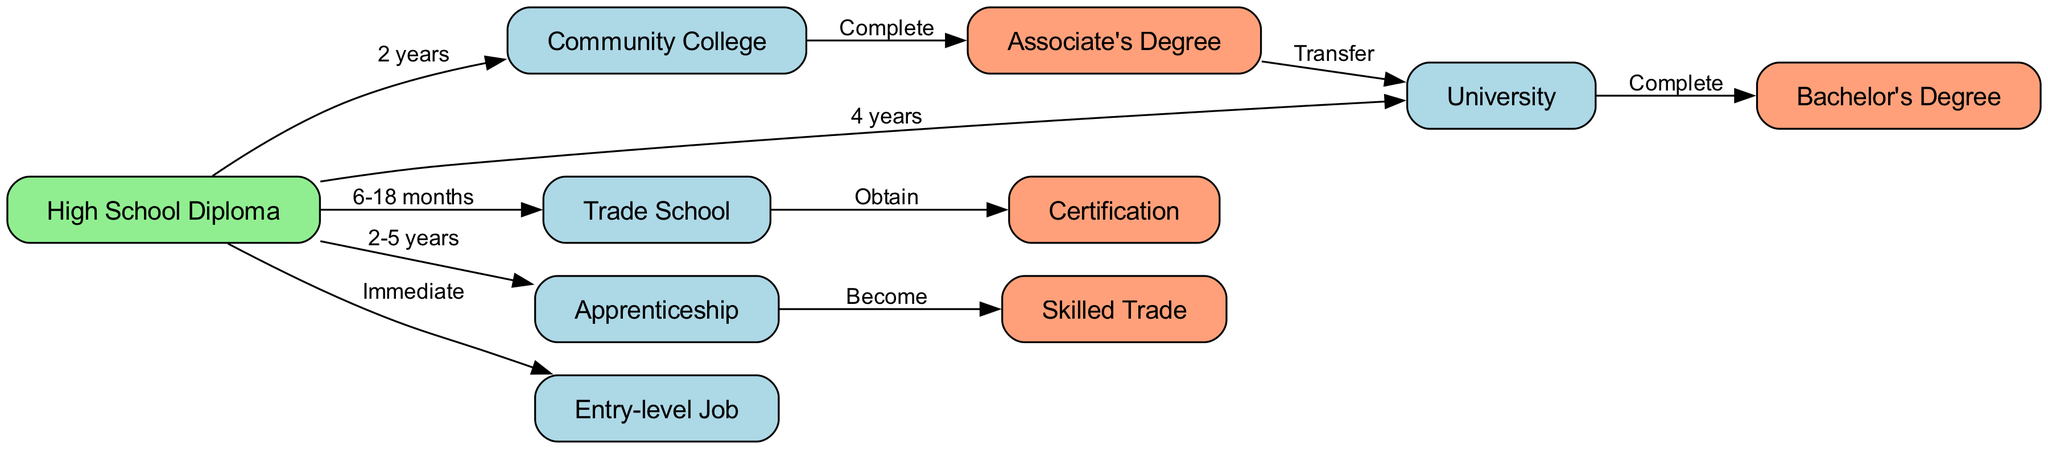What is the first step after obtaining a High School Diploma? According to the directed graph, after obtaining a High School Diploma, the first step can be to enter an Entry-level Job directly, which is labeled as "Immediate."
Answer: Entry-level Job How long does it take to complete a Trade School? The directed graph specifies that completing a Trade School takes between 6 to 18 months. The edge from the High School Diploma to Trade School indicates this time frame.
Answer: 6-18 months What can you obtain after completing Trade School? The diagram shows that after completing Trade School, you can obtain a Certification. This is indicated by the directed edge from Trade School to Certification.
Answer: Certification What are the educational paths available after a High School Diploma? The diagram lists five paths available after a High School Diploma: Community College, University, Trade School, Apprenticeship, and Entry-level Job. This is directly seen in the edges leading from the High School Diploma node.
Answer: 5 paths Which degree can you achieve by transferring from Community College? The directed graph illustrates that by transferring from Community College, you can achieve an Associate's Degree. This relationship is shown by the directed edge from Community College to Associate's Degree.
Answer: Associate's Degree What is the final outcome of completing an Apprenticeship? According to the diagram, the final outcome of completing an Apprenticeship is becoming a Skilled Trade. The directed edge from Apprenticeship to Skilled Trade reflects this conclusion.
Answer: Skilled Trade How many years does an Apprenticeship typically last? The directed graph indicates that an Apprenticeship typically lasts between 2 to 5 years. This duration is specified on the edge connecting the High School Diploma to Apprenticeship.
Answer: 2-5 years How many nodes are there in the diagram? The diagram consists of 10 nodes. The nodes are explicitly listed at the beginning, showcasing the different educational paths and outcomes.
Answer: 10 nodes What is the relationship between Associate's Degree and University? The directed graph shows that you can transfer from an Associate's Degree to a University. This connection is represented by the edge from Associate's Degree to University.
Answer: Transfer 